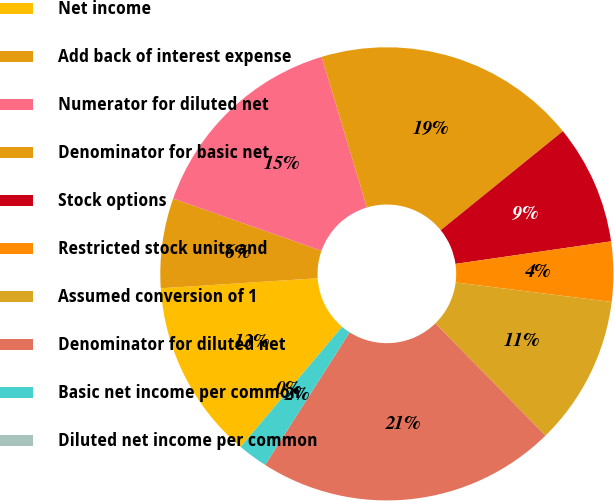Convert chart to OTSL. <chart><loc_0><loc_0><loc_500><loc_500><pie_chart><fcel>Net income<fcel>Add back of interest expense<fcel>Numerator for diluted net<fcel>Denominator for basic net<fcel>Stock options<fcel>Restricted stock units and<fcel>Assumed conversion of 1<fcel>Denominator for diluted net<fcel>Basic net income per common<fcel>Diluted net income per common<nl><fcel>12.82%<fcel>6.41%<fcel>14.96%<fcel>18.81%<fcel>8.55%<fcel>4.27%<fcel>10.68%<fcel>21.37%<fcel>2.14%<fcel>0.0%<nl></chart> 